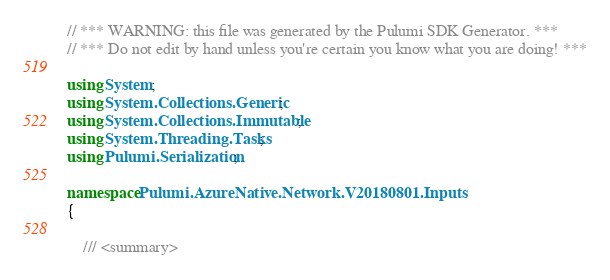Convert code to text. <code><loc_0><loc_0><loc_500><loc_500><_C#_>// *** WARNING: this file was generated by the Pulumi SDK Generator. ***
// *** Do not edit by hand unless you're certain you know what you are doing! ***

using System;
using System.Collections.Generic;
using System.Collections.Immutable;
using System.Threading.Tasks;
using Pulumi.Serialization;

namespace Pulumi.AzureNative.Network.V20180801.Inputs
{

    /// <summary></code> 